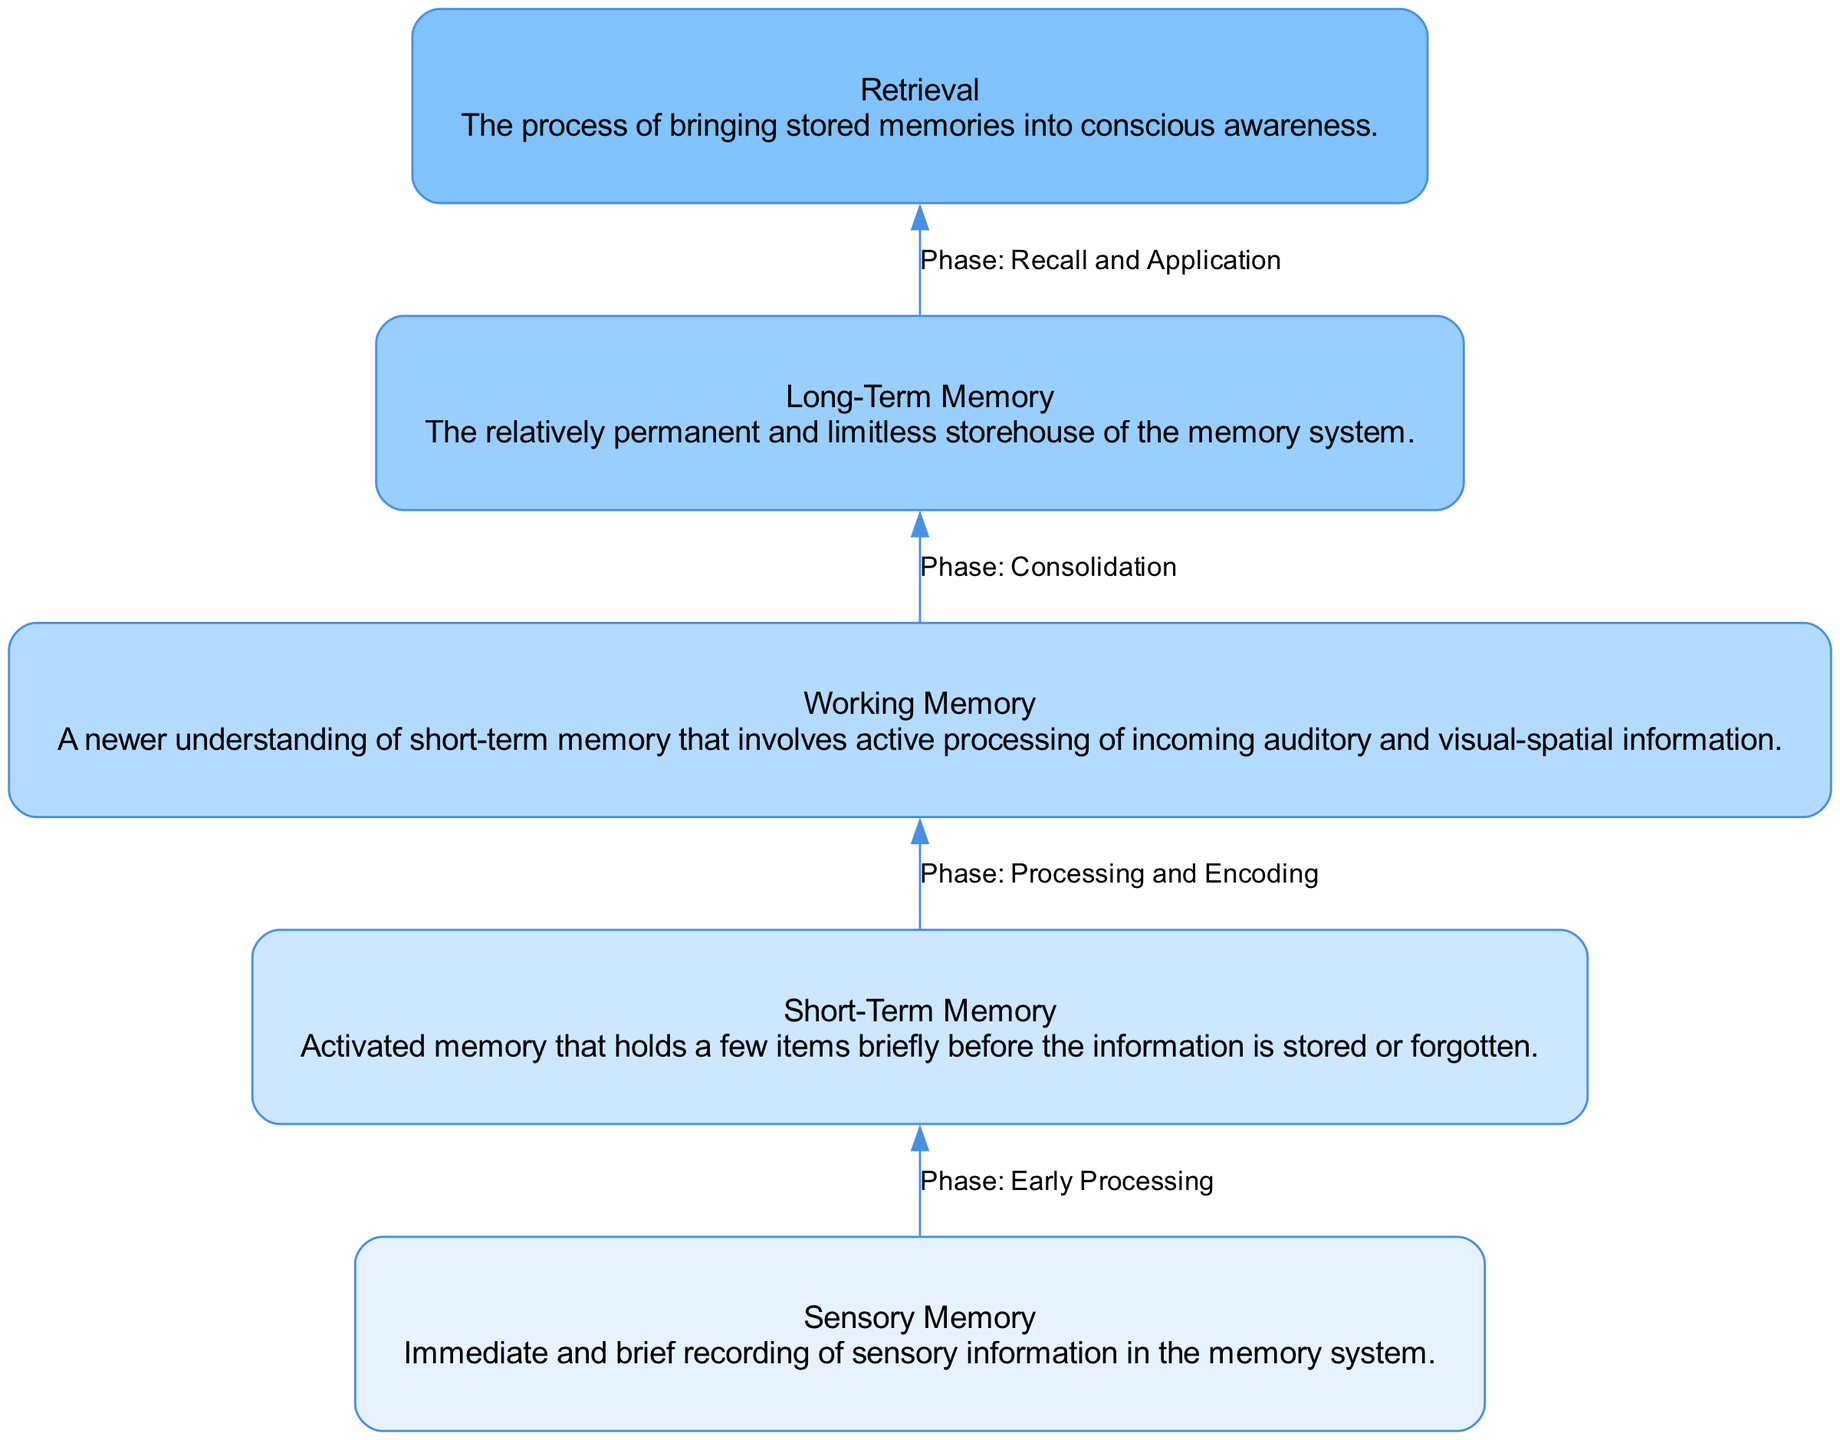What is the first phase in the memory consolidation flow? The flow chart indicates that the first phase of memory consolidation is "Sensory Memory," which is listed at the bottom of the diagram as the initial input.
Answer: Sensory Memory How many nodes are present in the diagram? The diagram contains five distinct nodes: Sensory Memory, Short-Term Memory, Working Memory, Long-Term Memory, and Retrieval. Therefore, there are a total of five nodes.
Answer: Five What does the second phase represent? The second phase of the diagram is identified as "Short-Term Memory," which follows directly after "Sensory Memory" in the flow.
Answer: Short-Term Memory Which phase comes after the "Working Memory"? According to the flow, "Working Memory" is followed by "Long-Term Memory," indicating this is the next phase in the consolidation process.
Answer: Long-Term Memory What is the connection labeled between "Short-Term Memory" and "Working Memory"? The edge connecting "Short-Term Memory" to "Working Memory" is labeled with the phase: "Processing and Encoding," indicating the activity that takes place between these two phases.
Answer: Processing and Encoding What is the primary function of "Long-Term Memory"? The chart describes "Long-Term Memory" as a relatively permanent and limitless storehouse, highlighting its role in the memory system.
Answer: Storehouse Which phase comes before "Retrieval"? The flow shows that "Long-Term Memory" precedes "Retrieval," meaning that information must first be consolidated into long-term memory before it can be retrieved.
Answer: Long-Term Memory What do all arrows in the diagram represent? Each arrow in the flow chart represents the transition between different phases of memory consolidation, indicating the sequence in which memory is processed and consolidated over time.
Answer: Transition 